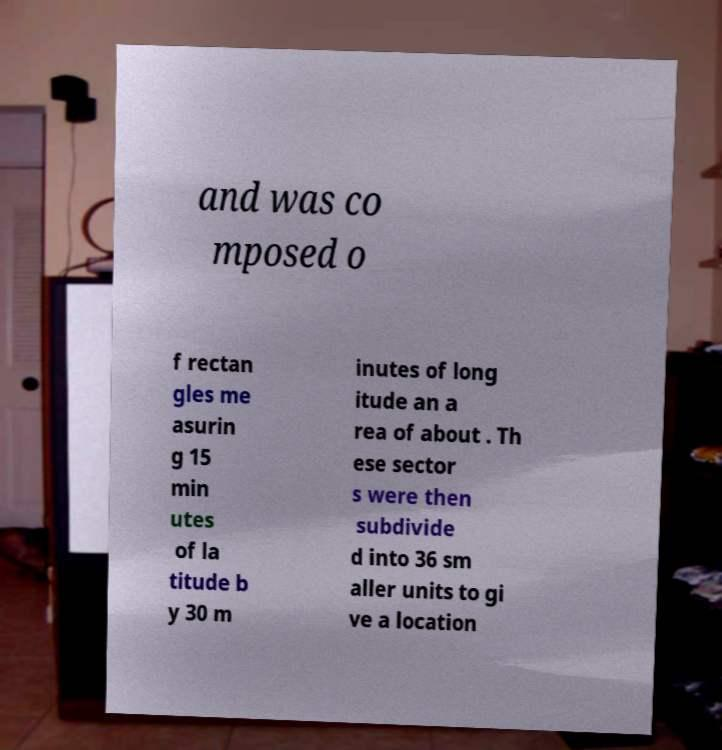Please identify and transcribe the text found in this image. and was co mposed o f rectan gles me asurin g 15 min utes of la titude b y 30 m inutes of long itude an a rea of about . Th ese sector s were then subdivide d into 36 sm aller units to gi ve a location 